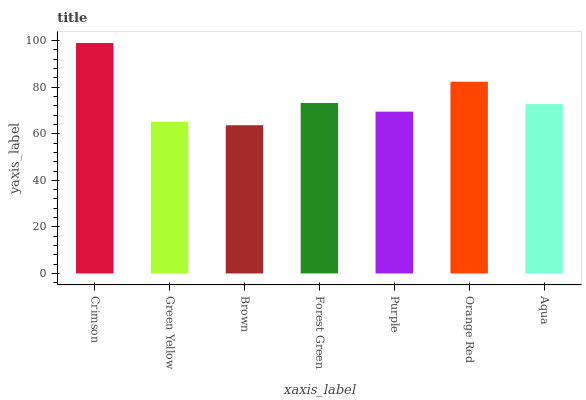Is Brown the minimum?
Answer yes or no. Yes. Is Crimson the maximum?
Answer yes or no. Yes. Is Green Yellow the minimum?
Answer yes or no. No. Is Green Yellow the maximum?
Answer yes or no. No. Is Crimson greater than Green Yellow?
Answer yes or no. Yes. Is Green Yellow less than Crimson?
Answer yes or no. Yes. Is Green Yellow greater than Crimson?
Answer yes or no. No. Is Crimson less than Green Yellow?
Answer yes or no. No. Is Aqua the high median?
Answer yes or no. Yes. Is Aqua the low median?
Answer yes or no. Yes. Is Purple the high median?
Answer yes or no. No. Is Green Yellow the low median?
Answer yes or no. No. 